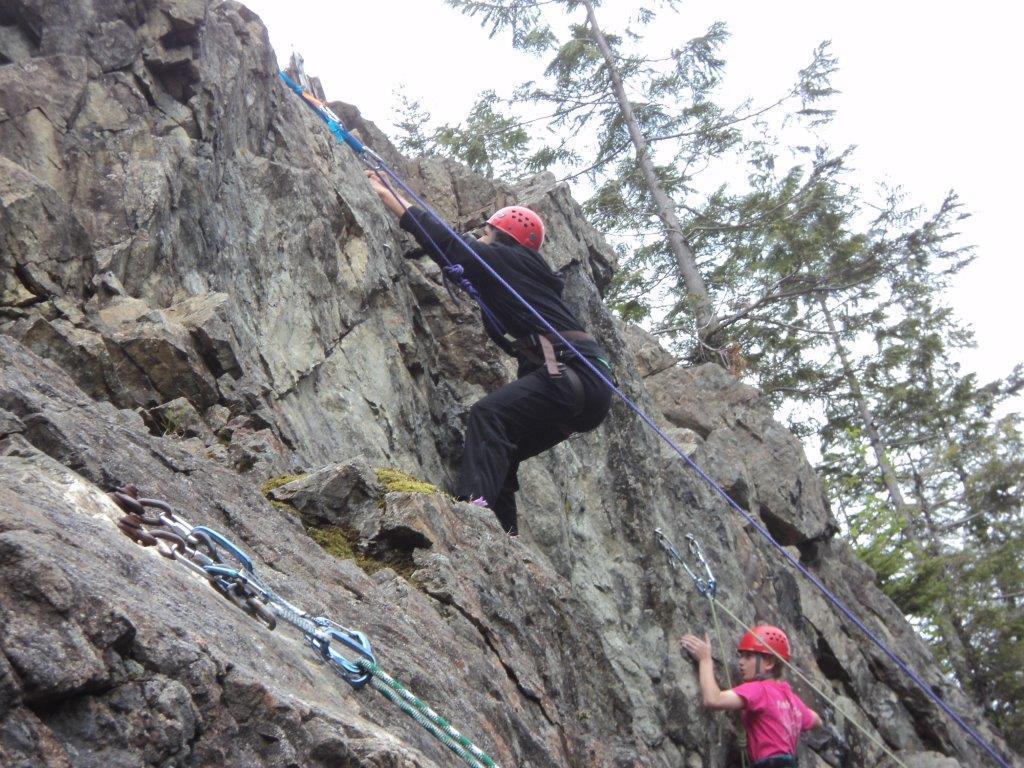Describe this image in one or two sentences. In the picture I can see two persons and they are climbing the rock. They are wearing the clothes and there is a helmet on their head. I can see the climbing ropes on the rock. There are trees on the right side. 